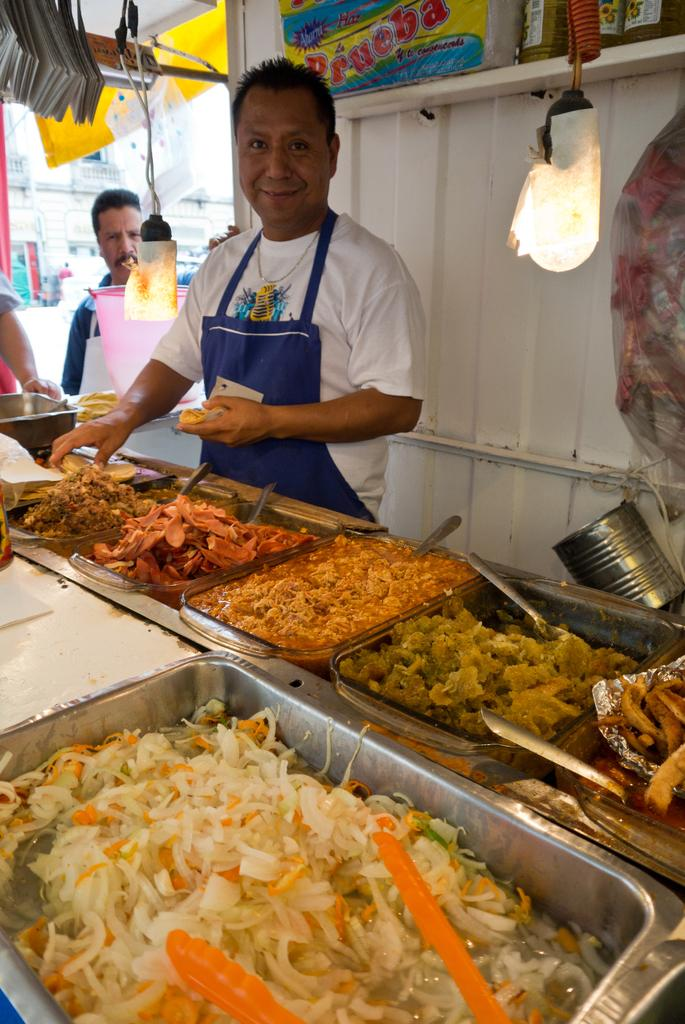What is the main subject of the image? There is a man standing in the image. What else can be seen in the image besides the man? There are food items in containers in the image. Are there any other people visible in the image? Yes, there are two people standing in the background of the image. How are the people in the image working together to achieve harmony? There is no indication in the image of people working together or achieving harmony, as the focus is on the man standing and the food items in containers. 